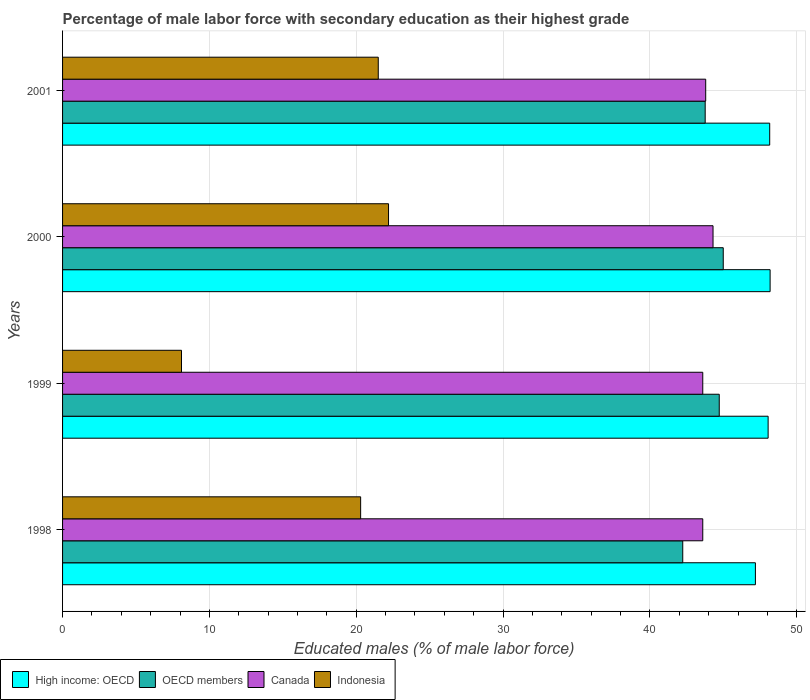How many different coloured bars are there?
Your response must be concise. 4. How many groups of bars are there?
Ensure brevity in your answer.  4. How many bars are there on the 2nd tick from the top?
Offer a very short reply. 4. In how many cases, is the number of bars for a given year not equal to the number of legend labels?
Your answer should be compact. 0. What is the percentage of male labor force with secondary education in Indonesia in 1998?
Ensure brevity in your answer.  20.3. Across all years, what is the maximum percentage of male labor force with secondary education in Indonesia?
Give a very brief answer. 22.2. Across all years, what is the minimum percentage of male labor force with secondary education in Indonesia?
Provide a succinct answer. 8.1. In which year was the percentage of male labor force with secondary education in OECD members maximum?
Offer a terse response. 2000. What is the total percentage of male labor force with secondary education in Canada in the graph?
Keep it short and to the point. 175.3. What is the difference between the percentage of male labor force with secondary education in Indonesia in 1999 and that in 2001?
Give a very brief answer. -13.4. What is the difference between the percentage of male labor force with secondary education in Canada in 2000 and the percentage of male labor force with secondary education in High income: OECD in 1999?
Offer a very short reply. -3.75. What is the average percentage of male labor force with secondary education in Canada per year?
Ensure brevity in your answer.  43.82. In the year 1998, what is the difference between the percentage of male labor force with secondary education in Indonesia and percentage of male labor force with secondary education in OECD members?
Offer a terse response. -21.94. In how many years, is the percentage of male labor force with secondary education in High income: OECD greater than 10 %?
Ensure brevity in your answer.  4. What is the ratio of the percentage of male labor force with secondary education in Indonesia in 1998 to that in 2000?
Your answer should be very brief. 0.91. What is the difference between the highest and the second highest percentage of male labor force with secondary education in OECD members?
Make the answer very short. 0.27. What is the difference between the highest and the lowest percentage of male labor force with secondary education in Canada?
Your response must be concise. 0.7. Is the sum of the percentage of male labor force with secondary education in Indonesia in 1999 and 2000 greater than the maximum percentage of male labor force with secondary education in OECD members across all years?
Give a very brief answer. No. What does the 4th bar from the top in 2000 represents?
Offer a terse response. High income: OECD. What does the 3rd bar from the bottom in 2000 represents?
Offer a terse response. Canada. How many bars are there?
Your answer should be compact. 16. How many years are there in the graph?
Your answer should be compact. 4. Are the values on the major ticks of X-axis written in scientific E-notation?
Provide a short and direct response. No. Does the graph contain any zero values?
Your answer should be compact. No. Does the graph contain grids?
Offer a very short reply. Yes. What is the title of the graph?
Make the answer very short. Percentage of male labor force with secondary education as their highest grade. What is the label or title of the X-axis?
Offer a very short reply. Educated males (% of male labor force). What is the label or title of the Y-axis?
Give a very brief answer. Years. What is the Educated males (% of male labor force) in High income: OECD in 1998?
Provide a short and direct response. 47.19. What is the Educated males (% of male labor force) of OECD members in 1998?
Keep it short and to the point. 42.24. What is the Educated males (% of male labor force) of Canada in 1998?
Offer a terse response. 43.6. What is the Educated males (% of male labor force) in Indonesia in 1998?
Your answer should be very brief. 20.3. What is the Educated males (% of male labor force) in High income: OECD in 1999?
Give a very brief answer. 48.05. What is the Educated males (% of male labor force) of OECD members in 1999?
Your response must be concise. 44.72. What is the Educated males (% of male labor force) in Canada in 1999?
Your response must be concise. 43.6. What is the Educated males (% of male labor force) in Indonesia in 1999?
Ensure brevity in your answer.  8.1. What is the Educated males (% of male labor force) of High income: OECD in 2000?
Keep it short and to the point. 48.19. What is the Educated males (% of male labor force) in OECD members in 2000?
Provide a short and direct response. 45. What is the Educated males (% of male labor force) in Canada in 2000?
Ensure brevity in your answer.  44.3. What is the Educated males (% of male labor force) of Indonesia in 2000?
Ensure brevity in your answer.  22.2. What is the Educated males (% of male labor force) in High income: OECD in 2001?
Offer a terse response. 48.16. What is the Educated males (% of male labor force) in OECD members in 2001?
Keep it short and to the point. 43.76. What is the Educated males (% of male labor force) of Canada in 2001?
Make the answer very short. 43.8. Across all years, what is the maximum Educated males (% of male labor force) in High income: OECD?
Your answer should be compact. 48.19. Across all years, what is the maximum Educated males (% of male labor force) of OECD members?
Offer a very short reply. 45. Across all years, what is the maximum Educated males (% of male labor force) of Canada?
Give a very brief answer. 44.3. Across all years, what is the maximum Educated males (% of male labor force) in Indonesia?
Offer a terse response. 22.2. Across all years, what is the minimum Educated males (% of male labor force) in High income: OECD?
Your response must be concise. 47.19. Across all years, what is the minimum Educated males (% of male labor force) in OECD members?
Offer a very short reply. 42.24. Across all years, what is the minimum Educated males (% of male labor force) in Canada?
Make the answer very short. 43.6. Across all years, what is the minimum Educated males (% of male labor force) of Indonesia?
Your response must be concise. 8.1. What is the total Educated males (% of male labor force) of High income: OECD in the graph?
Offer a very short reply. 191.58. What is the total Educated males (% of male labor force) of OECD members in the graph?
Provide a succinct answer. 175.72. What is the total Educated males (% of male labor force) in Canada in the graph?
Offer a very short reply. 175.3. What is the total Educated males (% of male labor force) of Indonesia in the graph?
Your response must be concise. 72.1. What is the difference between the Educated males (% of male labor force) in High income: OECD in 1998 and that in 1999?
Your answer should be very brief. -0.87. What is the difference between the Educated males (% of male labor force) in OECD members in 1998 and that in 1999?
Your answer should be compact. -2.49. What is the difference between the Educated males (% of male labor force) in High income: OECD in 1998 and that in 2000?
Your response must be concise. -1. What is the difference between the Educated males (% of male labor force) in OECD members in 1998 and that in 2000?
Keep it short and to the point. -2.76. What is the difference between the Educated males (% of male labor force) of Indonesia in 1998 and that in 2000?
Make the answer very short. -1.9. What is the difference between the Educated males (% of male labor force) in High income: OECD in 1998 and that in 2001?
Provide a short and direct response. -0.97. What is the difference between the Educated males (% of male labor force) in OECD members in 1998 and that in 2001?
Your response must be concise. -1.53. What is the difference between the Educated males (% of male labor force) in Canada in 1998 and that in 2001?
Make the answer very short. -0.2. What is the difference between the Educated males (% of male labor force) in High income: OECD in 1999 and that in 2000?
Your answer should be very brief. -0.14. What is the difference between the Educated males (% of male labor force) in OECD members in 1999 and that in 2000?
Provide a succinct answer. -0.27. What is the difference between the Educated males (% of male labor force) of Indonesia in 1999 and that in 2000?
Your response must be concise. -14.1. What is the difference between the Educated males (% of male labor force) of High income: OECD in 1999 and that in 2001?
Your response must be concise. -0.11. What is the difference between the Educated males (% of male labor force) of OECD members in 1999 and that in 2001?
Ensure brevity in your answer.  0.96. What is the difference between the Educated males (% of male labor force) in Canada in 1999 and that in 2001?
Make the answer very short. -0.2. What is the difference between the Educated males (% of male labor force) of Indonesia in 1999 and that in 2001?
Make the answer very short. -13.4. What is the difference between the Educated males (% of male labor force) of High income: OECD in 2000 and that in 2001?
Make the answer very short. 0.03. What is the difference between the Educated males (% of male labor force) of OECD members in 2000 and that in 2001?
Ensure brevity in your answer.  1.23. What is the difference between the Educated males (% of male labor force) of Canada in 2000 and that in 2001?
Make the answer very short. 0.5. What is the difference between the Educated males (% of male labor force) of Indonesia in 2000 and that in 2001?
Provide a succinct answer. 0.7. What is the difference between the Educated males (% of male labor force) of High income: OECD in 1998 and the Educated males (% of male labor force) of OECD members in 1999?
Provide a succinct answer. 2.46. What is the difference between the Educated males (% of male labor force) of High income: OECD in 1998 and the Educated males (% of male labor force) of Canada in 1999?
Provide a short and direct response. 3.59. What is the difference between the Educated males (% of male labor force) of High income: OECD in 1998 and the Educated males (% of male labor force) of Indonesia in 1999?
Your answer should be very brief. 39.09. What is the difference between the Educated males (% of male labor force) in OECD members in 1998 and the Educated males (% of male labor force) in Canada in 1999?
Your response must be concise. -1.36. What is the difference between the Educated males (% of male labor force) in OECD members in 1998 and the Educated males (% of male labor force) in Indonesia in 1999?
Keep it short and to the point. 34.14. What is the difference between the Educated males (% of male labor force) of Canada in 1998 and the Educated males (% of male labor force) of Indonesia in 1999?
Your response must be concise. 35.5. What is the difference between the Educated males (% of male labor force) of High income: OECD in 1998 and the Educated males (% of male labor force) of OECD members in 2000?
Offer a terse response. 2.19. What is the difference between the Educated males (% of male labor force) in High income: OECD in 1998 and the Educated males (% of male labor force) in Canada in 2000?
Offer a very short reply. 2.89. What is the difference between the Educated males (% of male labor force) in High income: OECD in 1998 and the Educated males (% of male labor force) in Indonesia in 2000?
Keep it short and to the point. 24.99. What is the difference between the Educated males (% of male labor force) in OECD members in 1998 and the Educated males (% of male labor force) in Canada in 2000?
Keep it short and to the point. -2.06. What is the difference between the Educated males (% of male labor force) in OECD members in 1998 and the Educated males (% of male labor force) in Indonesia in 2000?
Offer a very short reply. 20.04. What is the difference between the Educated males (% of male labor force) in Canada in 1998 and the Educated males (% of male labor force) in Indonesia in 2000?
Make the answer very short. 21.4. What is the difference between the Educated males (% of male labor force) of High income: OECD in 1998 and the Educated males (% of male labor force) of OECD members in 2001?
Provide a succinct answer. 3.42. What is the difference between the Educated males (% of male labor force) of High income: OECD in 1998 and the Educated males (% of male labor force) of Canada in 2001?
Give a very brief answer. 3.39. What is the difference between the Educated males (% of male labor force) in High income: OECD in 1998 and the Educated males (% of male labor force) in Indonesia in 2001?
Your answer should be very brief. 25.69. What is the difference between the Educated males (% of male labor force) of OECD members in 1998 and the Educated males (% of male labor force) of Canada in 2001?
Ensure brevity in your answer.  -1.56. What is the difference between the Educated males (% of male labor force) in OECD members in 1998 and the Educated males (% of male labor force) in Indonesia in 2001?
Provide a short and direct response. 20.74. What is the difference between the Educated males (% of male labor force) of Canada in 1998 and the Educated males (% of male labor force) of Indonesia in 2001?
Give a very brief answer. 22.1. What is the difference between the Educated males (% of male labor force) of High income: OECD in 1999 and the Educated males (% of male labor force) of OECD members in 2000?
Make the answer very short. 3.06. What is the difference between the Educated males (% of male labor force) of High income: OECD in 1999 and the Educated males (% of male labor force) of Canada in 2000?
Provide a short and direct response. 3.75. What is the difference between the Educated males (% of male labor force) in High income: OECD in 1999 and the Educated males (% of male labor force) in Indonesia in 2000?
Your response must be concise. 25.85. What is the difference between the Educated males (% of male labor force) in OECD members in 1999 and the Educated males (% of male labor force) in Canada in 2000?
Provide a short and direct response. 0.42. What is the difference between the Educated males (% of male labor force) in OECD members in 1999 and the Educated males (% of male labor force) in Indonesia in 2000?
Your answer should be very brief. 22.52. What is the difference between the Educated males (% of male labor force) of Canada in 1999 and the Educated males (% of male labor force) of Indonesia in 2000?
Ensure brevity in your answer.  21.4. What is the difference between the Educated males (% of male labor force) in High income: OECD in 1999 and the Educated males (% of male labor force) in OECD members in 2001?
Give a very brief answer. 4.29. What is the difference between the Educated males (% of male labor force) in High income: OECD in 1999 and the Educated males (% of male labor force) in Canada in 2001?
Offer a terse response. 4.25. What is the difference between the Educated males (% of male labor force) in High income: OECD in 1999 and the Educated males (% of male labor force) in Indonesia in 2001?
Offer a terse response. 26.55. What is the difference between the Educated males (% of male labor force) in OECD members in 1999 and the Educated males (% of male labor force) in Canada in 2001?
Offer a very short reply. 0.92. What is the difference between the Educated males (% of male labor force) in OECD members in 1999 and the Educated males (% of male labor force) in Indonesia in 2001?
Offer a terse response. 23.22. What is the difference between the Educated males (% of male labor force) of Canada in 1999 and the Educated males (% of male labor force) of Indonesia in 2001?
Your response must be concise. 22.1. What is the difference between the Educated males (% of male labor force) in High income: OECD in 2000 and the Educated males (% of male labor force) in OECD members in 2001?
Your response must be concise. 4.42. What is the difference between the Educated males (% of male labor force) in High income: OECD in 2000 and the Educated males (% of male labor force) in Canada in 2001?
Keep it short and to the point. 4.39. What is the difference between the Educated males (% of male labor force) of High income: OECD in 2000 and the Educated males (% of male labor force) of Indonesia in 2001?
Keep it short and to the point. 26.69. What is the difference between the Educated males (% of male labor force) of OECD members in 2000 and the Educated males (% of male labor force) of Canada in 2001?
Your answer should be very brief. 1.2. What is the difference between the Educated males (% of male labor force) in OECD members in 2000 and the Educated males (% of male labor force) in Indonesia in 2001?
Offer a very short reply. 23.5. What is the difference between the Educated males (% of male labor force) of Canada in 2000 and the Educated males (% of male labor force) of Indonesia in 2001?
Keep it short and to the point. 22.8. What is the average Educated males (% of male labor force) of High income: OECD per year?
Make the answer very short. 47.9. What is the average Educated males (% of male labor force) in OECD members per year?
Offer a terse response. 43.93. What is the average Educated males (% of male labor force) in Canada per year?
Your answer should be very brief. 43.83. What is the average Educated males (% of male labor force) of Indonesia per year?
Keep it short and to the point. 18.02. In the year 1998, what is the difference between the Educated males (% of male labor force) of High income: OECD and Educated males (% of male labor force) of OECD members?
Keep it short and to the point. 4.95. In the year 1998, what is the difference between the Educated males (% of male labor force) of High income: OECD and Educated males (% of male labor force) of Canada?
Your answer should be compact. 3.59. In the year 1998, what is the difference between the Educated males (% of male labor force) in High income: OECD and Educated males (% of male labor force) in Indonesia?
Provide a succinct answer. 26.89. In the year 1998, what is the difference between the Educated males (% of male labor force) in OECD members and Educated males (% of male labor force) in Canada?
Ensure brevity in your answer.  -1.36. In the year 1998, what is the difference between the Educated males (% of male labor force) in OECD members and Educated males (% of male labor force) in Indonesia?
Offer a very short reply. 21.94. In the year 1998, what is the difference between the Educated males (% of male labor force) of Canada and Educated males (% of male labor force) of Indonesia?
Provide a short and direct response. 23.3. In the year 1999, what is the difference between the Educated males (% of male labor force) of High income: OECD and Educated males (% of male labor force) of OECD members?
Your response must be concise. 3.33. In the year 1999, what is the difference between the Educated males (% of male labor force) in High income: OECD and Educated males (% of male labor force) in Canada?
Offer a terse response. 4.45. In the year 1999, what is the difference between the Educated males (% of male labor force) in High income: OECD and Educated males (% of male labor force) in Indonesia?
Provide a short and direct response. 39.95. In the year 1999, what is the difference between the Educated males (% of male labor force) of OECD members and Educated males (% of male labor force) of Canada?
Your answer should be very brief. 1.12. In the year 1999, what is the difference between the Educated males (% of male labor force) of OECD members and Educated males (% of male labor force) of Indonesia?
Provide a short and direct response. 36.62. In the year 1999, what is the difference between the Educated males (% of male labor force) in Canada and Educated males (% of male labor force) in Indonesia?
Keep it short and to the point. 35.5. In the year 2000, what is the difference between the Educated males (% of male labor force) in High income: OECD and Educated males (% of male labor force) in OECD members?
Give a very brief answer. 3.19. In the year 2000, what is the difference between the Educated males (% of male labor force) of High income: OECD and Educated males (% of male labor force) of Canada?
Make the answer very short. 3.89. In the year 2000, what is the difference between the Educated males (% of male labor force) of High income: OECD and Educated males (% of male labor force) of Indonesia?
Keep it short and to the point. 25.99. In the year 2000, what is the difference between the Educated males (% of male labor force) of OECD members and Educated males (% of male labor force) of Canada?
Your answer should be very brief. 0.7. In the year 2000, what is the difference between the Educated males (% of male labor force) of OECD members and Educated males (% of male labor force) of Indonesia?
Your answer should be compact. 22.8. In the year 2000, what is the difference between the Educated males (% of male labor force) in Canada and Educated males (% of male labor force) in Indonesia?
Your response must be concise. 22.1. In the year 2001, what is the difference between the Educated males (% of male labor force) in High income: OECD and Educated males (% of male labor force) in OECD members?
Your answer should be compact. 4.39. In the year 2001, what is the difference between the Educated males (% of male labor force) of High income: OECD and Educated males (% of male labor force) of Canada?
Your response must be concise. 4.36. In the year 2001, what is the difference between the Educated males (% of male labor force) of High income: OECD and Educated males (% of male labor force) of Indonesia?
Ensure brevity in your answer.  26.66. In the year 2001, what is the difference between the Educated males (% of male labor force) in OECD members and Educated males (% of male labor force) in Canada?
Ensure brevity in your answer.  -0.04. In the year 2001, what is the difference between the Educated males (% of male labor force) of OECD members and Educated males (% of male labor force) of Indonesia?
Offer a terse response. 22.26. In the year 2001, what is the difference between the Educated males (% of male labor force) in Canada and Educated males (% of male labor force) in Indonesia?
Offer a very short reply. 22.3. What is the ratio of the Educated males (% of male labor force) of OECD members in 1998 to that in 1999?
Give a very brief answer. 0.94. What is the ratio of the Educated males (% of male labor force) in Canada in 1998 to that in 1999?
Offer a terse response. 1. What is the ratio of the Educated males (% of male labor force) of Indonesia in 1998 to that in 1999?
Make the answer very short. 2.51. What is the ratio of the Educated males (% of male labor force) of High income: OECD in 1998 to that in 2000?
Give a very brief answer. 0.98. What is the ratio of the Educated males (% of male labor force) in OECD members in 1998 to that in 2000?
Offer a terse response. 0.94. What is the ratio of the Educated males (% of male labor force) in Canada in 1998 to that in 2000?
Give a very brief answer. 0.98. What is the ratio of the Educated males (% of male labor force) in Indonesia in 1998 to that in 2000?
Offer a very short reply. 0.91. What is the ratio of the Educated males (% of male labor force) in High income: OECD in 1998 to that in 2001?
Your response must be concise. 0.98. What is the ratio of the Educated males (% of male labor force) in OECD members in 1998 to that in 2001?
Give a very brief answer. 0.97. What is the ratio of the Educated males (% of male labor force) in Canada in 1998 to that in 2001?
Keep it short and to the point. 1. What is the ratio of the Educated males (% of male labor force) of Indonesia in 1998 to that in 2001?
Your answer should be compact. 0.94. What is the ratio of the Educated males (% of male labor force) in High income: OECD in 1999 to that in 2000?
Your answer should be very brief. 1. What is the ratio of the Educated males (% of male labor force) in OECD members in 1999 to that in 2000?
Give a very brief answer. 0.99. What is the ratio of the Educated males (% of male labor force) in Canada in 1999 to that in 2000?
Give a very brief answer. 0.98. What is the ratio of the Educated males (% of male labor force) in Indonesia in 1999 to that in 2000?
Give a very brief answer. 0.36. What is the ratio of the Educated males (% of male labor force) in High income: OECD in 1999 to that in 2001?
Provide a succinct answer. 1. What is the ratio of the Educated males (% of male labor force) of OECD members in 1999 to that in 2001?
Your answer should be very brief. 1.02. What is the ratio of the Educated males (% of male labor force) in Indonesia in 1999 to that in 2001?
Offer a terse response. 0.38. What is the ratio of the Educated males (% of male labor force) of OECD members in 2000 to that in 2001?
Offer a terse response. 1.03. What is the ratio of the Educated males (% of male labor force) of Canada in 2000 to that in 2001?
Offer a terse response. 1.01. What is the ratio of the Educated males (% of male labor force) of Indonesia in 2000 to that in 2001?
Provide a succinct answer. 1.03. What is the difference between the highest and the second highest Educated males (% of male labor force) in High income: OECD?
Your response must be concise. 0.03. What is the difference between the highest and the second highest Educated males (% of male labor force) in OECD members?
Give a very brief answer. 0.27. What is the difference between the highest and the second highest Educated males (% of male labor force) in Canada?
Your response must be concise. 0.5. What is the difference between the highest and the lowest Educated males (% of male labor force) of OECD members?
Your answer should be very brief. 2.76. What is the difference between the highest and the lowest Educated males (% of male labor force) in Canada?
Offer a terse response. 0.7. 